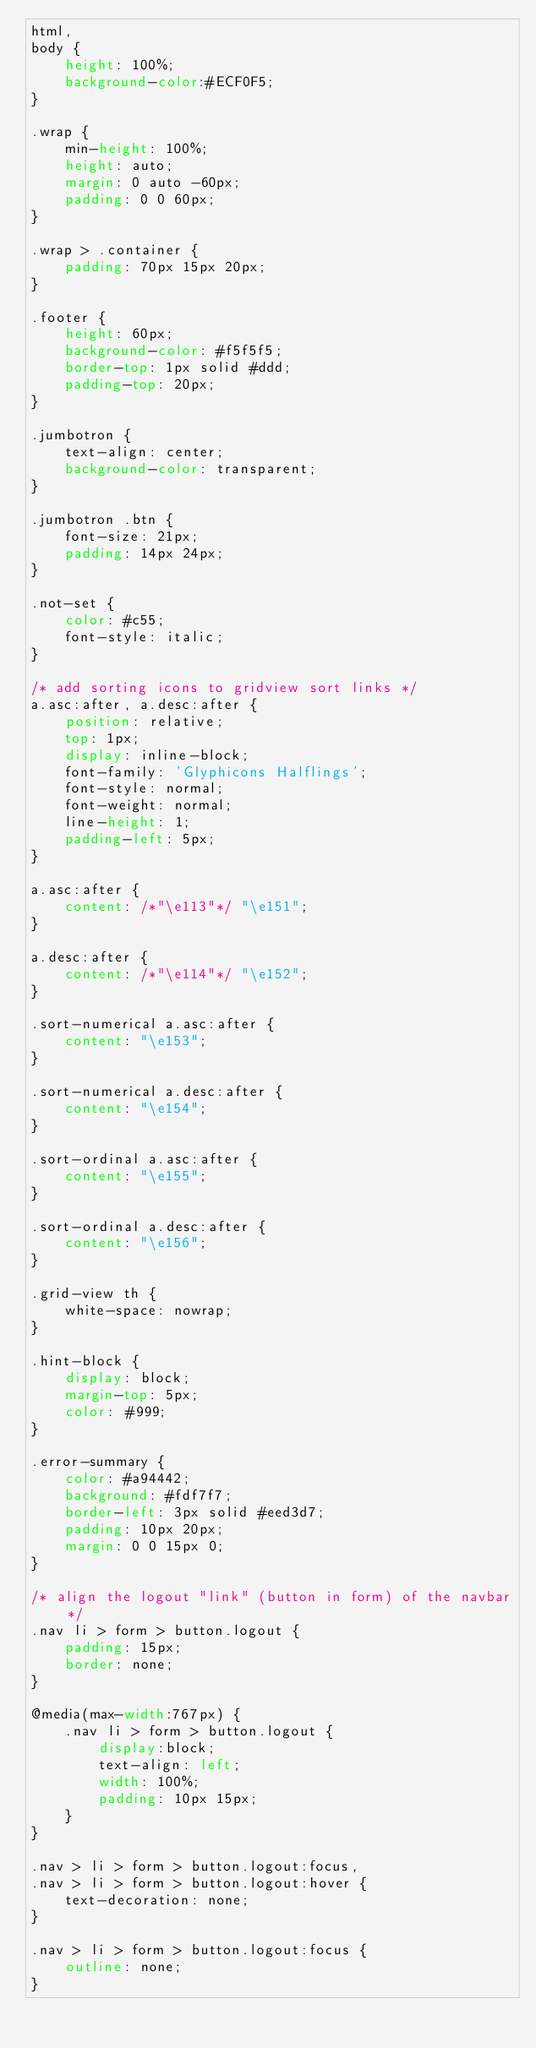Convert code to text. <code><loc_0><loc_0><loc_500><loc_500><_CSS_>html,
body {
    height: 100%;
    background-color:#ECF0F5;
}

.wrap {
    min-height: 100%;
    height: auto;
    margin: 0 auto -60px;
    padding: 0 0 60px;
}

.wrap > .container {
    padding: 70px 15px 20px;
}

.footer {
    height: 60px;
    background-color: #f5f5f5;
    border-top: 1px solid #ddd;
    padding-top: 20px;
}

.jumbotron {
    text-align: center;
    background-color: transparent;
}

.jumbotron .btn {
    font-size: 21px;
    padding: 14px 24px;
}

.not-set {
    color: #c55;
    font-style: italic;
}

/* add sorting icons to gridview sort links */
a.asc:after, a.desc:after {
    position: relative;
    top: 1px;
    display: inline-block;
    font-family: 'Glyphicons Halflings';
    font-style: normal;
    font-weight: normal;
    line-height: 1;
    padding-left: 5px;
}

a.asc:after {
    content: /*"\e113"*/ "\e151";
}

a.desc:after {
    content: /*"\e114"*/ "\e152";
}

.sort-numerical a.asc:after {
    content: "\e153";
}

.sort-numerical a.desc:after {
    content: "\e154";
}

.sort-ordinal a.asc:after {
    content: "\e155";
}

.sort-ordinal a.desc:after {
    content: "\e156";
}

.grid-view th {
    white-space: nowrap;
}

.hint-block {
    display: block;
    margin-top: 5px;
    color: #999;
}

.error-summary {
    color: #a94442;
    background: #fdf7f7;
    border-left: 3px solid #eed3d7;
    padding: 10px 20px;
    margin: 0 0 15px 0;
}

/* align the logout "link" (button in form) of the navbar */
.nav li > form > button.logout {
    padding: 15px;
    border: none;
}

@media(max-width:767px) {
    .nav li > form > button.logout {
        display:block;
        text-align: left;
        width: 100%;
        padding: 10px 15px;
    }
}

.nav > li > form > button.logout:focus,
.nav > li > form > button.logout:hover {
    text-decoration: none;
}

.nav > li > form > button.logout:focus {
    outline: none;
}
</code> 